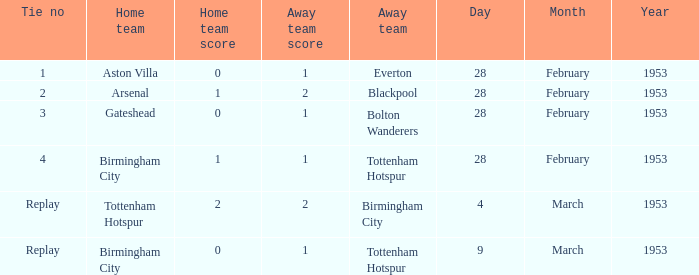Can you parse all the data within this table? {'header': ['Tie no', 'Home team', 'Home team score', 'Away team score', 'Away team', 'Day', 'Month', 'Year'], 'rows': [['1', 'Aston Villa', '0', '1', 'Everton', '28', 'February', '1953'], ['2', 'Arsenal', '1', '2', 'Blackpool', '28', 'February', '1953'], ['3', 'Gateshead', '0', '1', 'Bolton Wanderers', '28', 'February', '1953'], ['4', 'Birmingham City', '1', '1', 'Tottenham Hotspur', '28', 'February', '1953'], ['Replay', 'Tottenham Hotspur', '2', '2', 'Birmingham City', '4', 'March', '1953'], ['Replay', 'Birmingham City', '0', '1', 'Tottenham Hotspur', '9', 'March', '1953']]} As the home team, what is aston villa's score? 0–1. 